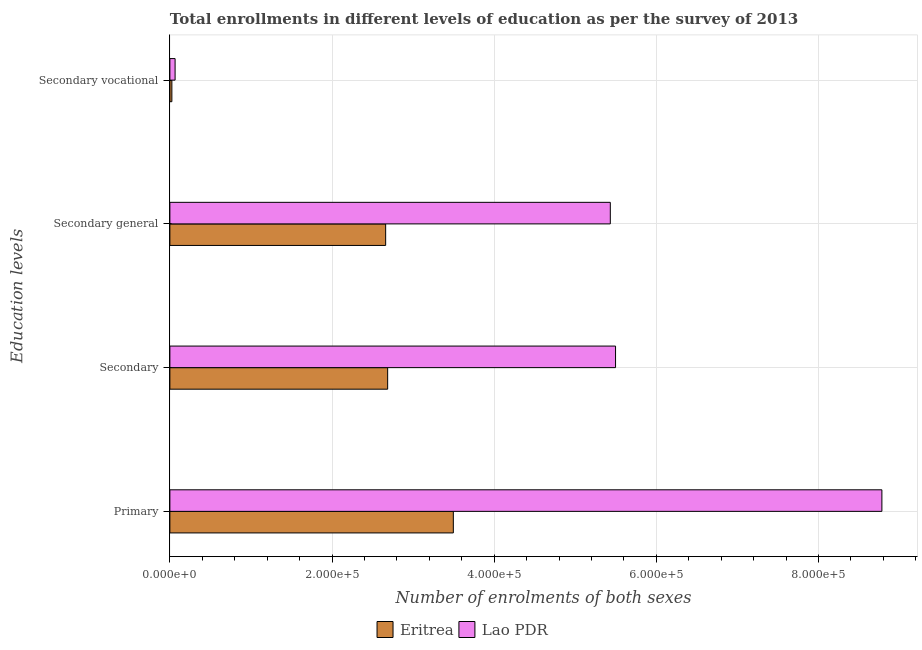How many different coloured bars are there?
Provide a succinct answer. 2. Are the number of bars on each tick of the Y-axis equal?
Your response must be concise. Yes. What is the label of the 4th group of bars from the top?
Give a very brief answer. Primary. What is the number of enrolments in secondary education in Lao PDR?
Your answer should be very brief. 5.50e+05. Across all countries, what is the maximum number of enrolments in secondary general education?
Offer a very short reply. 5.43e+05. Across all countries, what is the minimum number of enrolments in secondary general education?
Make the answer very short. 2.66e+05. In which country was the number of enrolments in secondary education maximum?
Make the answer very short. Lao PDR. In which country was the number of enrolments in primary education minimum?
Your response must be concise. Eritrea. What is the total number of enrolments in secondary general education in the graph?
Ensure brevity in your answer.  8.09e+05. What is the difference between the number of enrolments in secondary vocational education in Lao PDR and that in Eritrea?
Offer a terse response. 3976. What is the difference between the number of enrolments in secondary education in Lao PDR and the number of enrolments in secondary vocational education in Eritrea?
Provide a short and direct response. 5.47e+05. What is the average number of enrolments in secondary vocational education per country?
Provide a succinct answer. 4458. What is the difference between the number of enrolments in primary education and number of enrolments in secondary education in Lao PDR?
Give a very brief answer. 3.29e+05. In how many countries, is the number of enrolments in secondary general education greater than 640000 ?
Your answer should be very brief. 0. What is the ratio of the number of enrolments in primary education in Eritrea to that in Lao PDR?
Ensure brevity in your answer.  0.4. Is the number of enrolments in secondary vocational education in Eritrea less than that in Lao PDR?
Your answer should be compact. Yes. What is the difference between the highest and the second highest number of enrolments in secondary general education?
Provide a short and direct response. 2.77e+05. What is the difference between the highest and the lowest number of enrolments in secondary education?
Offer a very short reply. 2.81e+05. Is it the case that in every country, the sum of the number of enrolments in secondary general education and number of enrolments in primary education is greater than the sum of number of enrolments in secondary vocational education and number of enrolments in secondary education?
Make the answer very short. No. What does the 2nd bar from the top in Secondary general represents?
Keep it short and to the point. Eritrea. What does the 1st bar from the bottom in Primary represents?
Offer a terse response. Eritrea. Are all the bars in the graph horizontal?
Ensure brevity in your answer.  Yes. What is the difference between two consecutive major ticks on the X-axis?
Your answer should be compact. 2.00e+05. Are the values on the major ticks of X-axis written in scientific E-notation?
Provide a short and direct response. Yes. Does the graph contain grids?
Offer a terse response. Yes. Where does the legend appear in the graph?
Your answer should be very brief. Bottom center. How are the legend labels stacked?
Your answer should be compact. Horizontal. What is the title of the graph?
Keep it short and to the point. Total enrollments in different levels of education as per the survey of 2013. What is the label or title of the X-axis?
Provide a succinct answer. Number of enrolments of both sexes. What is the label or title of the Y-axis?
Provide a short and direct response. Education levels. What is the Number of enrolments of both sexes in Eritrea in Primary?
Offer a terse response. 3.50e+05. What is the Number of enrolments of both sexes of Lao PDR in Primary?
Your response must be concise. 8.78e+05. What is the Number of enrolments of both sexes of Eritrea in Secondary?
Your answer should be compact. 2.69e+05. What is the Number of enrolments of both sexes in Lao PDR in Secondary?
Offer a very short reply. 5.50e+05. What is the Number of enrolments of both sexes of Eritrea in Secondary general?
Give a very brief answer. 2.66e+05. What is the Number of enrolments of both sexes of Lao PDR in Secondary general?
Keep it short and to the point. 5.43e+05. What is the Number of enrolments of both sexes in Eritrea in Secondary vocational?
Provide a succinct answer. 2470. What is the Number of enrolments of both sexes in Lao PDR in Secondary vocational?
Your response must be concise. 6446. Across all Education levels, what is the maximum Number of enrolments of both sexes in Eritrea?
Provide a short and direct response. 3.50e+05. Across all Education levels, what is the maximum Number of enrolments of both sexes in Lao PDR?
Ensure brevity in your answer.  8.78e+05. Across all Education levels, what is the minimum Number of enrolments of both sexes of Eritrea?
Ensure brevity in your answer.  2470. Across all Education levels, what is the minimum Number of enrolments of both sexes of Lao PDR?
Offer a very short reply. 6446. What is the total Number of enrolments of both sexes in Eritrea in the graph?
Ensure brevity in your answer.  8.87e+05. What is the total Number of enrolments of both sexes in Lao PDR in the graph?
Provide a succinct answer. 1.98e+06. What is the difference between the Number of enrolments of both sexes in Eritrea in Primary and that in Secondary?
Your answer should be compact. 8.10e+04. What is the difference between the Number of enrolments of both sexes in Lao PDR in Primary and that in Secondary?
Make the answer very short. 3.29e+05. What is the difference between the Number of enrolments of both sexes in Eritrea in Primary and that in Secondary general?
Make the answer very short. 8.35e+04. What is the difference between the Number of enrolments of both sexes of Lao PDR in Primary and that in Secondary general?
Your answer should be compact. 3.35e+05. What is the difference between the Number of enrolments of both sexes in Eritrea in Primary and that in Secondary vocational?
Your answer should be very brief. 3.47e+05. What is the difference between the Number of enrolments of both sexes of Lao PDR in Primary and that in Secondary vocational?
Your answer should be compact. 8.72e+05. What is the difference between the Number of enrolments of both sexes of Eritrea in Secondary and that in Secondary general?
Ensure brevity in your answer.  2470. What is the difference between the Number of enrolments of both sexes of Lao PDR in Secondary and that in Secondary general?
Offer a terse response. 6446. What is the difference between the Number of enrolments of both sexes of Eritrea in Secondary and that in Secondary vocational?
Your response must be concise. 2.66e+05. What is the difference between the Number of enrolments of both sexes of Lao PDR in Secondary and that in Secondary vocational?
Your answer should be compact. 5.43e+05. What is the difference between the Number of enrolments of both sexes of Eritrea in Secondary general and that in Secondary vocational?
Your answer should be very brief. 2.64e+05. What is the difference between the Number of enrolments of both sexes of Lao PDR in Secondary general and that in Secondary vocational?
Make the answer very short. 5.37e+05. What is the difference between the Number of enrolments of both sexes in Eritrea in Primary and the Number of enrolments of both sexes in Lao PDR in Secondary?
Offer a very short reply. -2.00e+05. What is the difference between the Number of enrolments of both sexes in Eritrea in Primary and the Number of enrolments of both sexes in Lao PDR in Secondary general?
Give a very brief answer. -1.94e+05. What is the difference between the Number of enrolments of both sexes in Eritrea in Primary and the Number of enrolments of both sexes in Lao PDR in Secondary vocational?
Keep it short and to the point. 3.43e+05. What is the difference between the Number of enrolments of both sexes in Eritrea in Secondary and the Number of enrolments of both sexes in Lao PDR in Secondary general?
Offer a terse response. -2.75e+05. What is the difference between the Number of enrolments of both sexes in Eritrea in Secondary and the Number of enrolments of both sexes in Lao PDR in Secondary vocational?
Provide a short and direct response. 2.62e+05. What is the difference between the Number of enrolments of both sexes in Eritrea in Secondary general and the Number of enrolments of both sexes in Lao PDR in Secondary vocational?
Keep it short and to the point. 2.60e+05. What is the average Number of enrolments of both sexes in Eritrea per Education levels?
Your response must be concise. 2.22e+05. What is the average Number of enrolments of both sexes in Lao PDR per Education levels?
Your answer should be very brief. 4.94e+05. What is the difference between the Number of enrolments of both sexes in Eritrea and Number of enrolments of both sexes in Lao PDR in Primary?
Provide a succinct answer. -5.29e+05. What is the difference between the Number of enrolments of both sexes in Eritrea and Number of enrolments of both sexes in Lao PDR in Secondary?
Your response must be concise. -2.81e+05. What is the difference between the Number of enrolments of both sexes in Eritrea and Number of enrolments of both sexes in Lao PDR in Secondary general?
Your answer should be compact. -2.77e+05. What is the difference between the Number of enrolments of both sexes in Eritrea and Number of enrolments of both sexes in Lao PDR in Secondary vocational?
Your answer should be very brief. -3976. What is the ratio of the Number of enrolments of both sexes of Eritrea in Primary to that in Secondary?
Make the answer very short. 1.3. What is the ratio of the Number of enrolments of both sexes of Lao PDR in Primary to that in Secondary?
Offer a very short reply. 1.6. What is the ratio of the Number of enrolments of both sexes in Eritrea in Primary to that in Secondary general?
Ensure brevity in your answer.  1.31. What is the ratio of the Number of enrolments of both sexes in Lao PDR in Primary to that in Secondary general?
Your response must be concise. 1.62. What is the ratio of the Number of enrolments of both sexes of Eritrea in Primary to that in Secondary vocational?
Your response must be concise. 141.56. What is the ratio of the Number of enrolments of both sexes of Lao PDR in Primary to that in Secondary vocational?
Ensure brevity in your answer.  136.25. What is the ratio of the Number of enrolments of both sexes of Eritrea in Secondary to that in Secondary general?
Your response must be concise. 1.01. What is the ratio of the Number of enrolments of both sexes of Lao PDR in Secondary to that in Secondary general?
Ensure brevity in your answer.  1.01. What is the ratio of the Number of enrolments of both sexes in Eritrea in Secondary to that in Secondary vocational?
Your answer should be very brief. 108.76. What is the ratio of the Number of enrolments of both sexes in Lao PDR in Secondary to that in Secondary vocational?
Give a very brief answer. 85.28. What is the ratio of the Number of enrolments of both sexes in Eritrea in Secondary general to that in Secondary vocational?
Ensure brevity in your answer.  107.76. What is the ratio of the Number of enrolments of both sexes of Lao PDR in Secondary general to that in Secondary vocational?
Ensure brevity in your answer.  84.28. What is the difference between the highest and the second highest Number of enrolments of both sexes of Eritrea?
Give a very brief answer. 8.10e+04. What is the difference between the highest and the second highest Number of enrolments of both sexes of Lao PDR?
Ensure brevity in your answer.  3.29e+05. What is the difference between the highest and the lowest Number of enrolments of both sexes of Eritrea?
Keep it short and to the point. 3.47e+05. What is the difference between the highest and the lowest Number of enrolments of both sexes in Lao PDR?
Provide a short and direct response. 8.72e+05. 